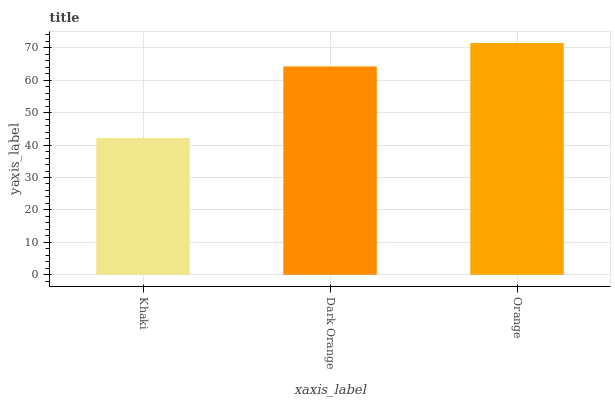Is Dark Orange the minimum?
Answer yes or no. No. Is Dark Orange the maximum?
Answer yes or no. No. Is Dark Orange greater than Khaki?
Answer yes or no. Yes. Is Khaki less than Dark Orange?
Answer yes or no. Yes. Is Khaki greater than Dark Orange?
Answer yes or no. No. Is Dark Orange less than Khaki?
Answer yes or no. No. Is Dark Orange the high median?
Answer yes or no. Yes. Is Dark Orange the low median?
Answer yes or no. Yes. Is Orange the high median?
Answer yes or no. No. Is Khaki the low median?
Answer yes or no. No. 